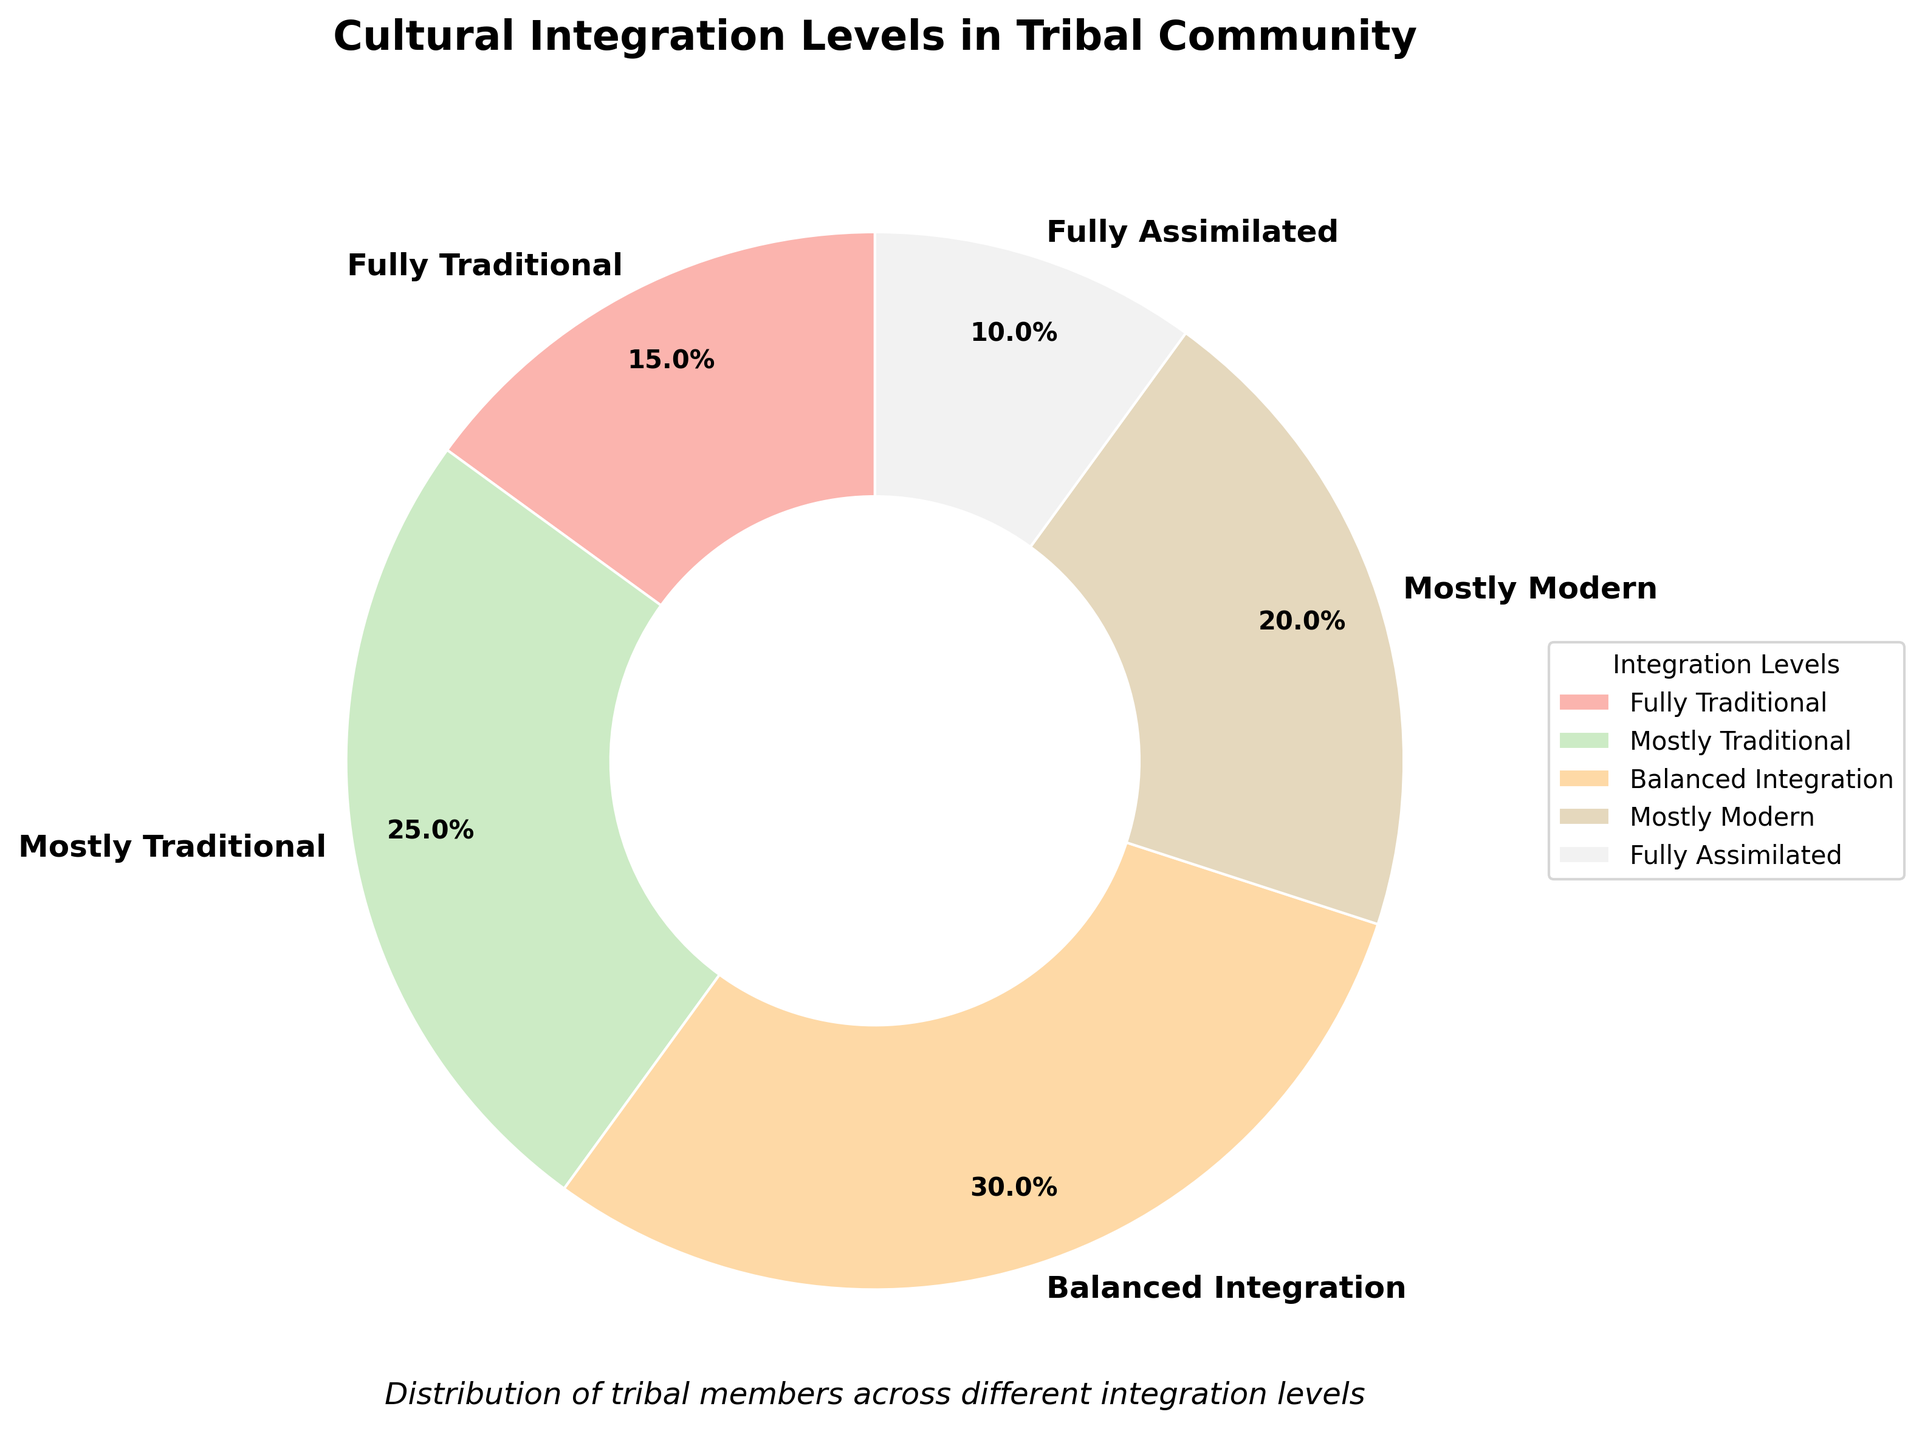What percentage of tribal members are fully traditional? Look at the percentage associated with 'Fully Traditional' on the pie chart. The label indicates 15%.
Answer: 15% How many percentage points more are 'Mostly Traditional' compared to 'Fully Assimilated'? The 'Mostly Traditional' category is 25% and 'Fully Assimilated' is 10%. Subtract the percentage of 'Fully Assimilated' from 'Mostly Traditional': 25% - 10% = 15%.
Answer: 15% What is the sum of 'Fully Traditional' and 'Fully Assimilated' percentages? Add the percentages of 'Fully Traditional' and 'Fully Assimilated': 15% + 10% = 25%.
Answer: 25% Which integration level category has the highest percentage? Identify and compare all the percentages; 'Balanced Integration' is the highest at 30%.
Answer: Balanced Integration How many percentage points less is 'Mostly Modern' compared to 'Balanced Integration'? The 'Balanced Integration' category is 30% and 'Mostly Modern' is 20%. Subtract 'Mostly Modern' from 'Balanced Integration': 30% - 20% = 10%.
Answer: 10% What is the average percentage of 'Fully Traditional', 'Mostly Traditional', and 'Mostly Modern'? Sum the percentages of these three categories and divide by 3: (15% + 25% + 20%) / 3 = 60% / 3 = 20%.
Answer: 20% If the 'Fully Traditional' and 'Fully Assimilated' categories were combined, what would their new percentage be? Add the percentages of 'Fully Traditional' and 'Fully Assimilated': 15% + 10% = 25%.
Answer: 25% Which category has the smallest percentage? Identify the smallest percentage among the categories; 'Fully Assimilated' is the smallest at 10%.
Answer: Fully Assimilated Is the combined percentage of 'Mostly Traditional' and 'Mostly Modern' greater than 'Balanced Integration'? Sum the percentages of 'Mostly Traditional' and 'Mostly Modern': 25% + 20% = 45%. Compare 45% to 'Balanced Integration's 30%. Yes, 45% is greater.
Answer: Yes What is the percentage difference between the largest and smallest categories? Identify the largest percentage (Balanced Integration at 30%) and the smallest (Fully Assimilated at 10%). Subtract the smallest from the largest: 30% - 10% = 20%.
Answer: 20% 